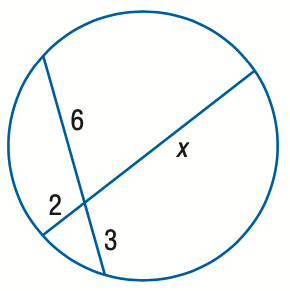Question: Find x. Assume that segments that appear to be tangent are tangent.
Choices:
A. 6
B. 7
C. 8
D. 9
Answer with the letter. Answer: D 